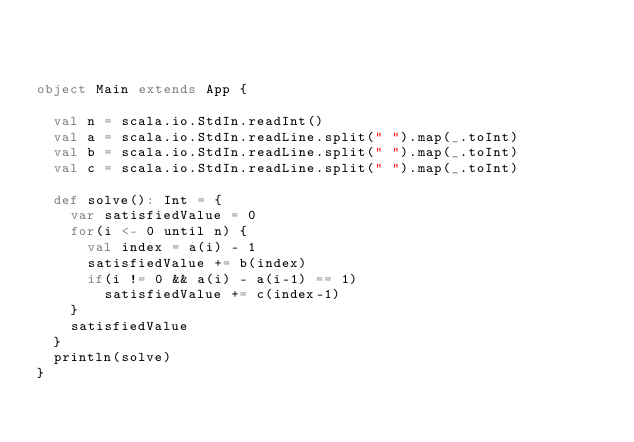<code> <loc_0><loc_0><loc_500><loc_500><_Scala_>


object Main extends App {

  val n = scala.io.StdIn.readInt()
  val a = scala.io.StdIn.readLine.split(" ").map(_.toInt)
  val b = scala.io.StdIn.readLine.split(" ").map(_.toInt)
  val c = scala.io.StdIn.readLine.split(" ").map(_.toInt)

  def solve(): Int = {
    var satisfiedValue = 0
    for(i <- 0 until n) {
      val index = a(i) - 1
      satisfiedValue += b(index)
      if(i != 0 && a(i) - a(i-1) == 1)
        satisfiedValue += c(index-1)
    }
    satisfiedValue
  }
  println(solve)
}
</code> 